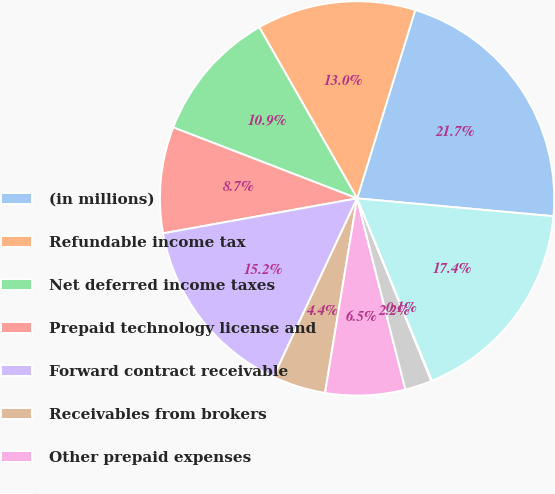<chart> <loc_0><loc_0><loc_500><loc_500><pie_chart><fcel>(in millions)<fcel>Refundable income tax<fcel>Net deferred income taxes<fcel>Prepaid technology license and<fcel>Forward contract receivable<fcel>Receivables from brokers<fcel>Other prepaid expenses<fcel>Prepaid insurance<fcel>Other<fcel>Total<nl><fcel>21.68%<fcel>13.03%<fcel>10.87%<fcel>8.7%<fcel>15.19%<fcel>4.37%<fcel>6.54%<fcel>2.21%<fcel>0.05%<fcel>17.36%<nl></chart> 